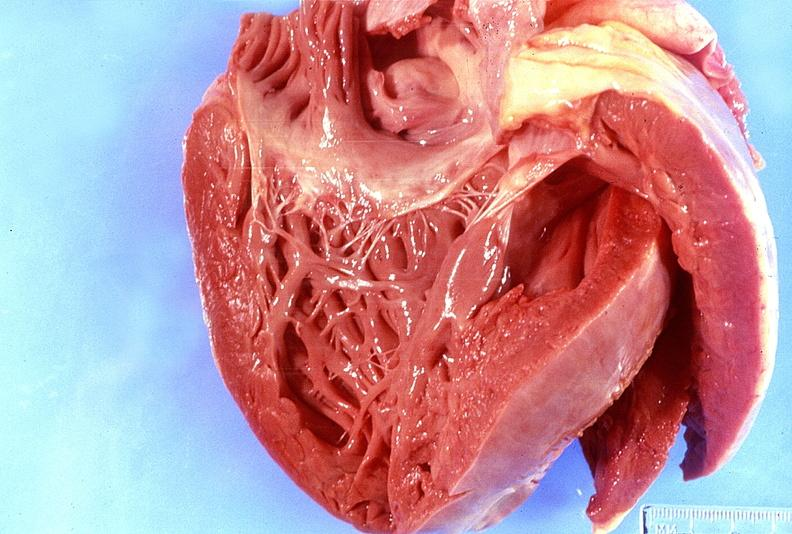does this image show normal tricuspid valve?
Answer the question using a single word or phrase. Yes 